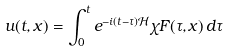Convert formula to latex. <formula><loc_0><loc_0><loc_500><loc_500>u ( t , x ) = \int _ { 0 } ^ { t } e ^ { - i ( t - \tau ) \mathcal { H } } \chi F ( \tau , x ) \, d \tau</formula> 